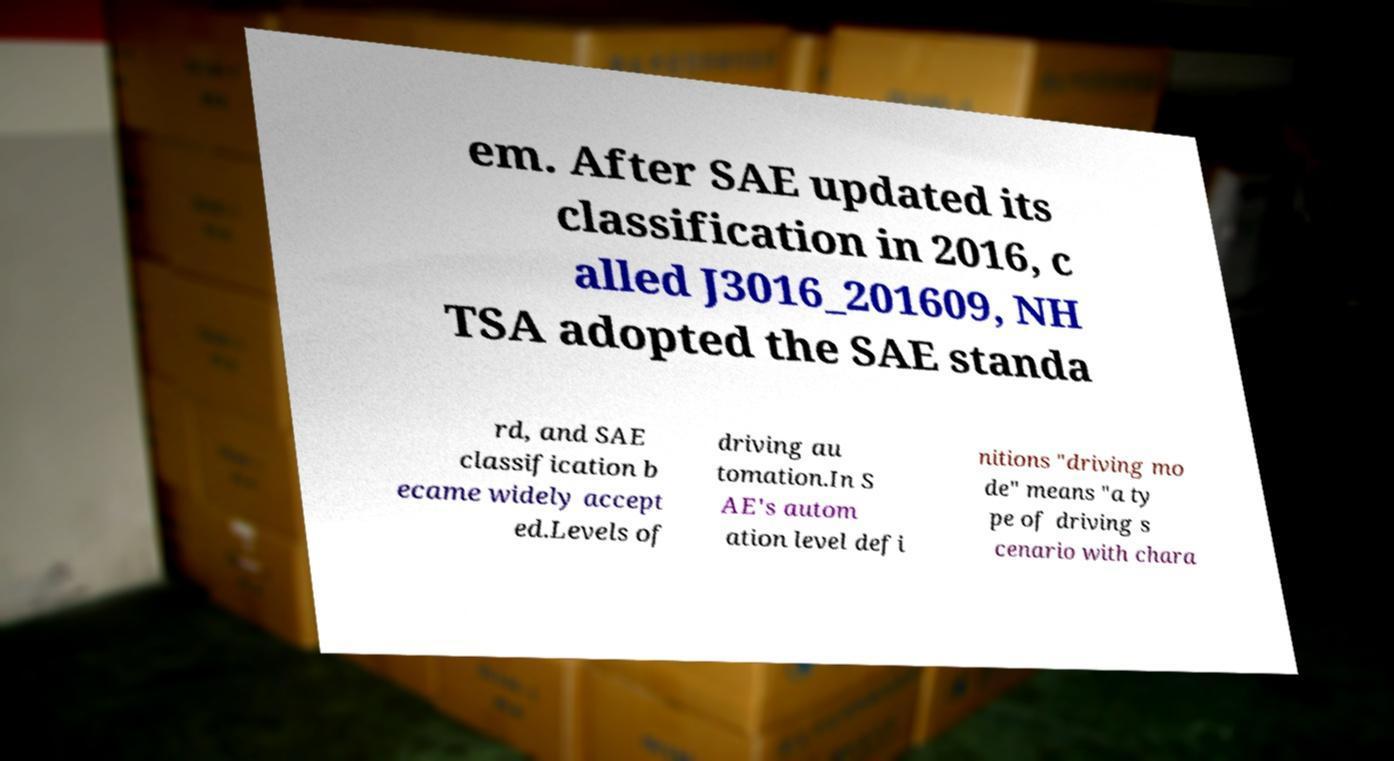For documentation purposes, I need the text within this image transcribed. Could you provide that? em. After SAE updated its classification in 2016, c alled J3016_201609, NH TSA adopted the SAE standa rd, and SAE classification b ecame widely accept ed.Levels of driving au tomation.In S AE's autom ation level defi nitions "driving mo de" means "a ty pe of driving s cenario with chara 